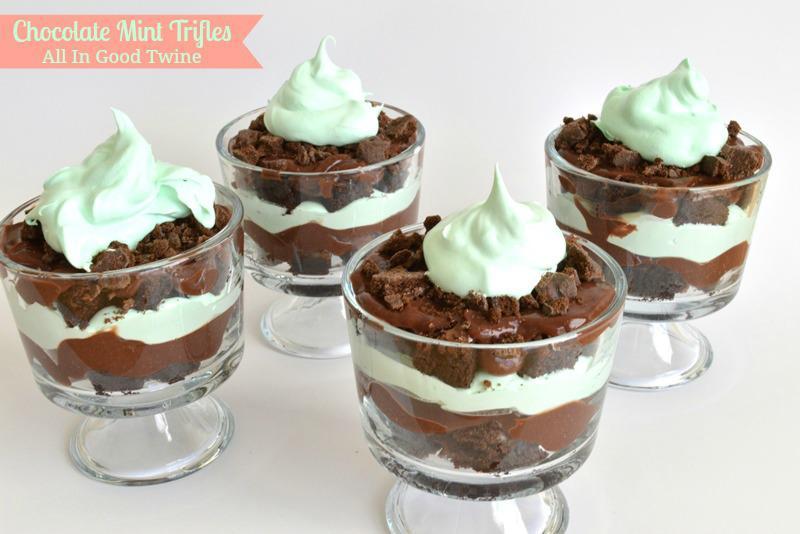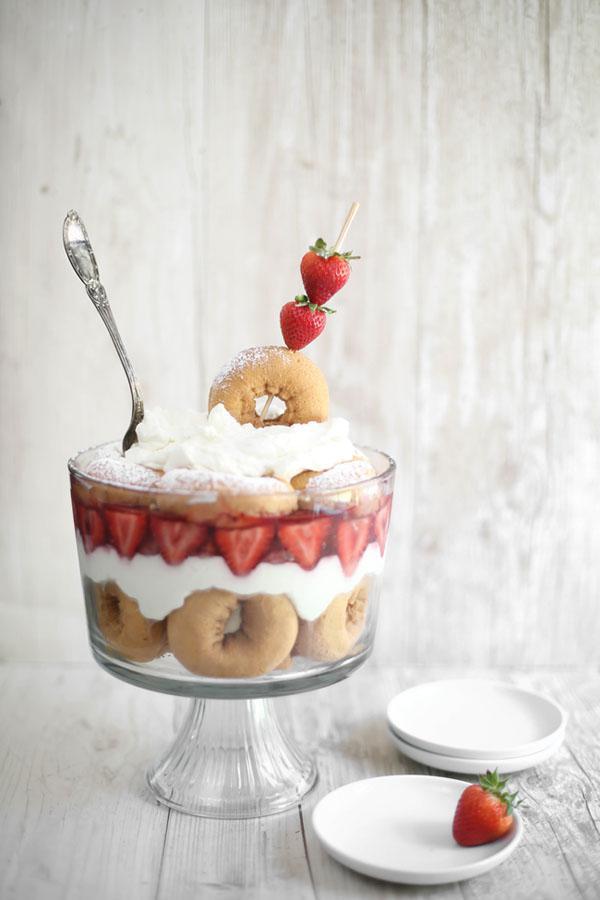The first image is the image on the left, the second image is the image on the right. Assess this claim about the two images: "A bottle of irish cream sits near the desserts in one of the images.". Correct or not? Answer yes or no. No. The first image is the image on the left, the second image is the image on the right. Given the left and right images, does the statement "A bottle of liqueur is visible behind a creamy dessert with brown chunks in it." hold true? Answer yes or no. No. 